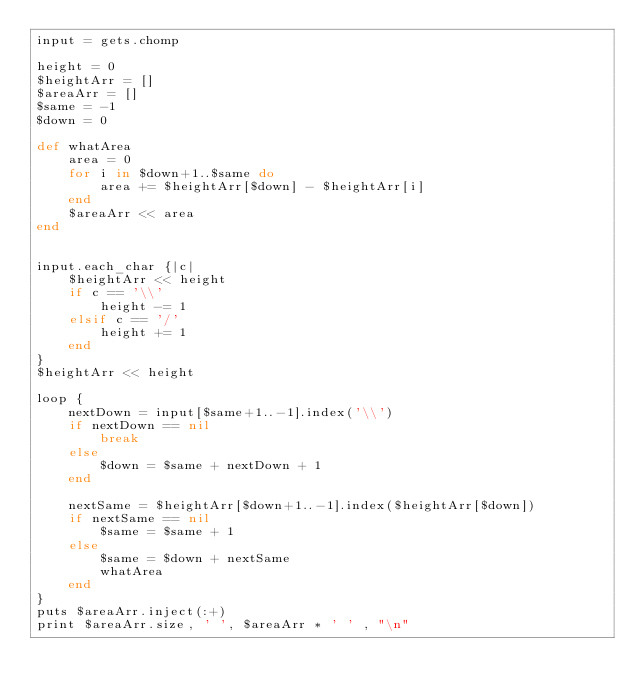<code> <loc_0><loc_0><loc_500><loc_500><_Ruby_>input = gets.chomp

height = 0
$heightArr = []
$areaArr = []
$same = -1
$down = 0

def whatArea
    area = 0
    for i in $down+1..$same do
        area += $heightArr[$down] - $heightArr[i]
    end
    $areaArr << area
end


input.each_char {|c|
    $heightArr << height
    if c == '\\'
        height -= 1
    elsif c == '/'
        height += 1
    end
}
$heightArr << height

loop {
    nextDown = input[$same+1..-1].index('\\')
    if nextDown == nil
        break
    else
        $down = $same + nextDown + 1
    end

    nextSame = $heightArr[$down+1..-1].index($heightArr[$down])
    if nextSame == nil
        $same = $same + 1
    else
        $same = $down + nextSame
        whatArea
    end
}
puts $areaArr.inject(:+)
print $areaArr.size, ' ', $areaArr * ' ' , "\n"</code> 